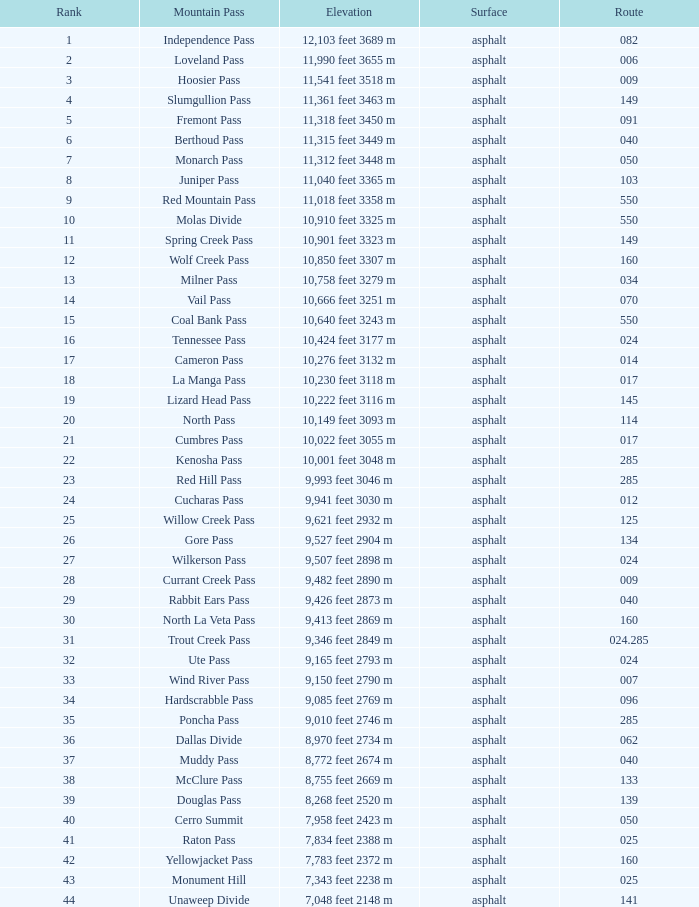On what Route is the mountain with a Rank less than 33 and an Elevation of 11,312 feet 3448 m? 50.0. 